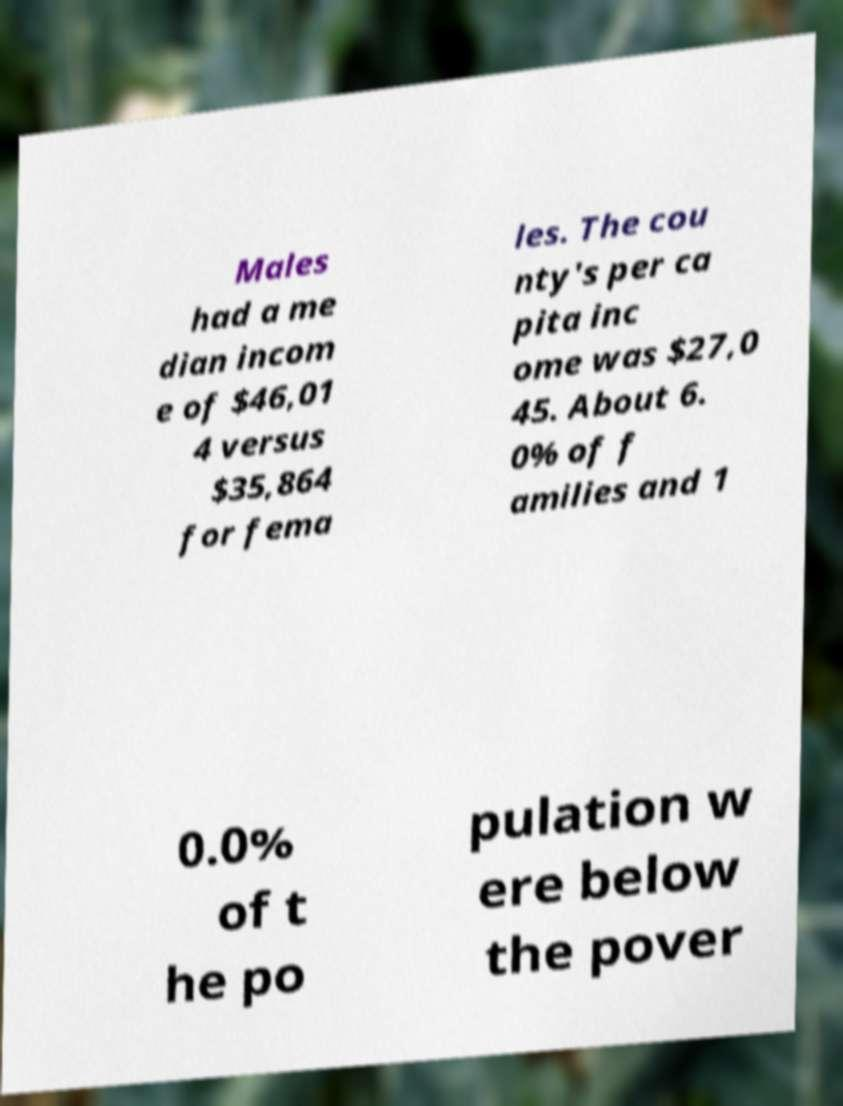There's text embedded in this image that I need extracted. Can you transcribe it verbatim? Males had a me dian incom e of $46,01 4 versus $35,864 for fema les. The cou nty's per ca pita inc ome was $27,0 45. About 6. 0% of f amilies and 1 0.0% of t he po pulation w ere below the pover 